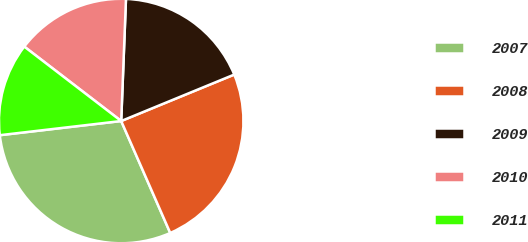Convert chart. <chart><loc_0><loc_0><loc_500><loc_500><pie_chart><fcel>2007<fcel>2008<fcel>2009<fcel>2010<fcel>2011<nl><fcel>29.72%<fcel>24.63%<fcel>18.17%<fcel>15.2%<fcel>12.27%<nl></chart> 